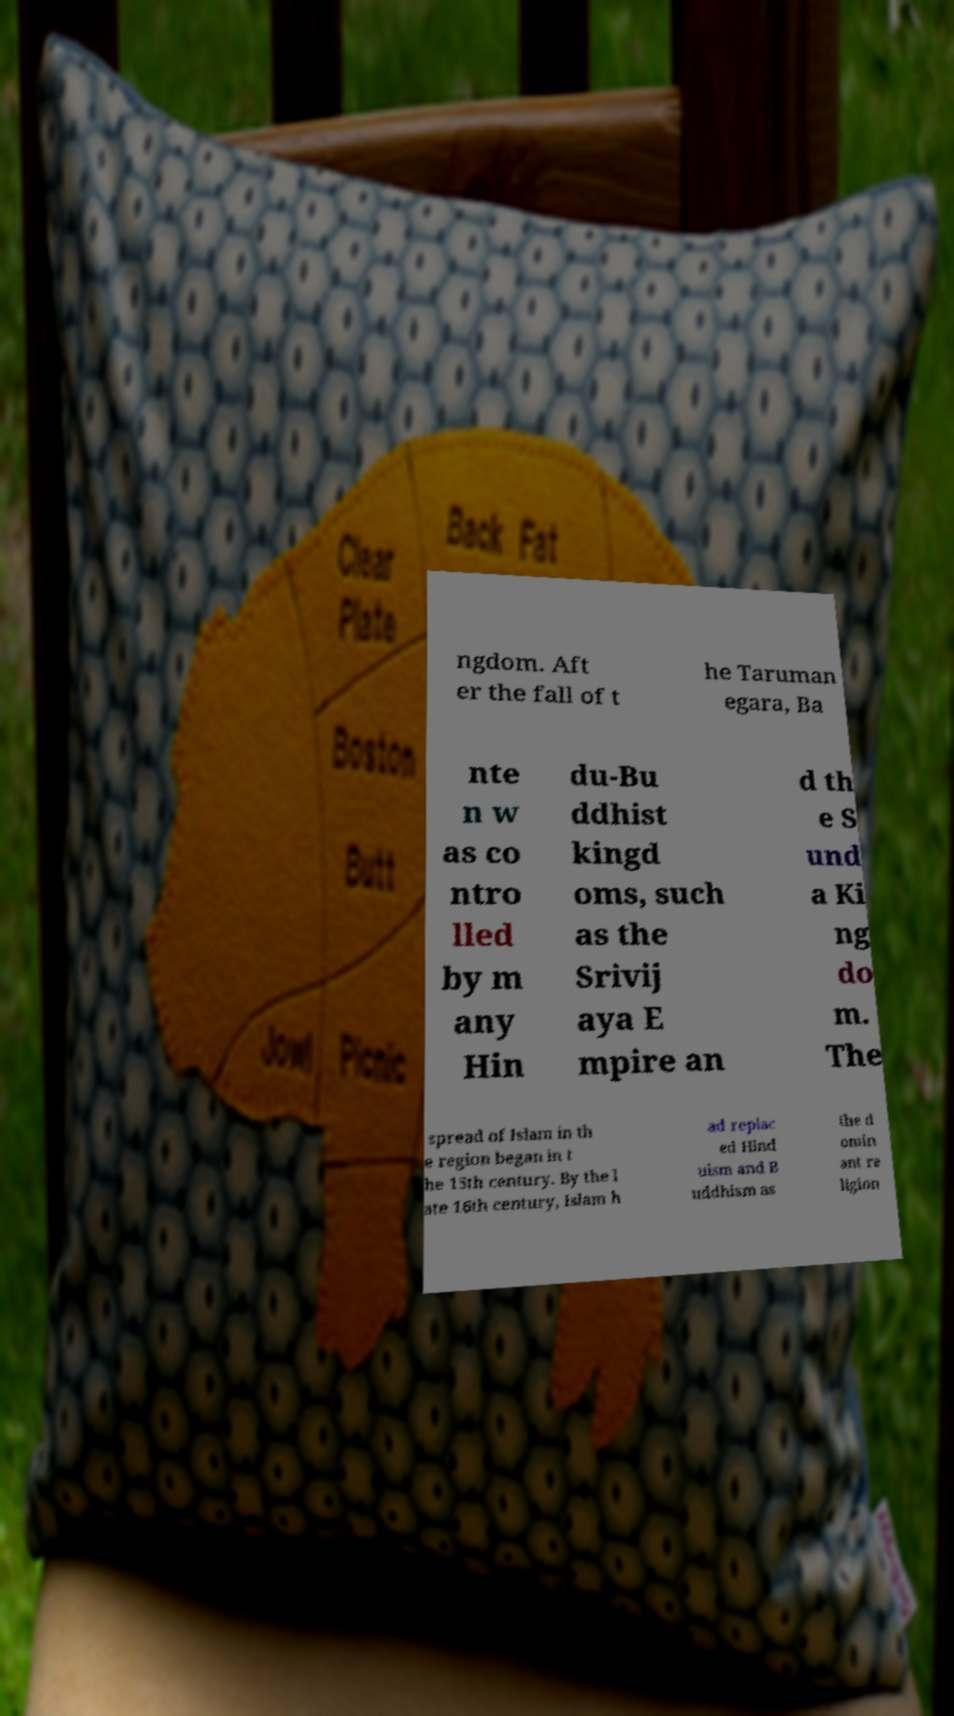Could you extract and type out the text from this image? ngdom. Aft er the fall of t he Taruman egara, Ba nte n w as co ntro lled by m any Hin du-Bu ddhist kingd oms, such as the Srivij aya E mpire an d th e S und a Ki ng do m. The spread of Islam in th e region began in t he 15th century. By the l ate 16th century, Islam h ad replac ed Hind uism and B uddhism as the d omin ant re ligion 